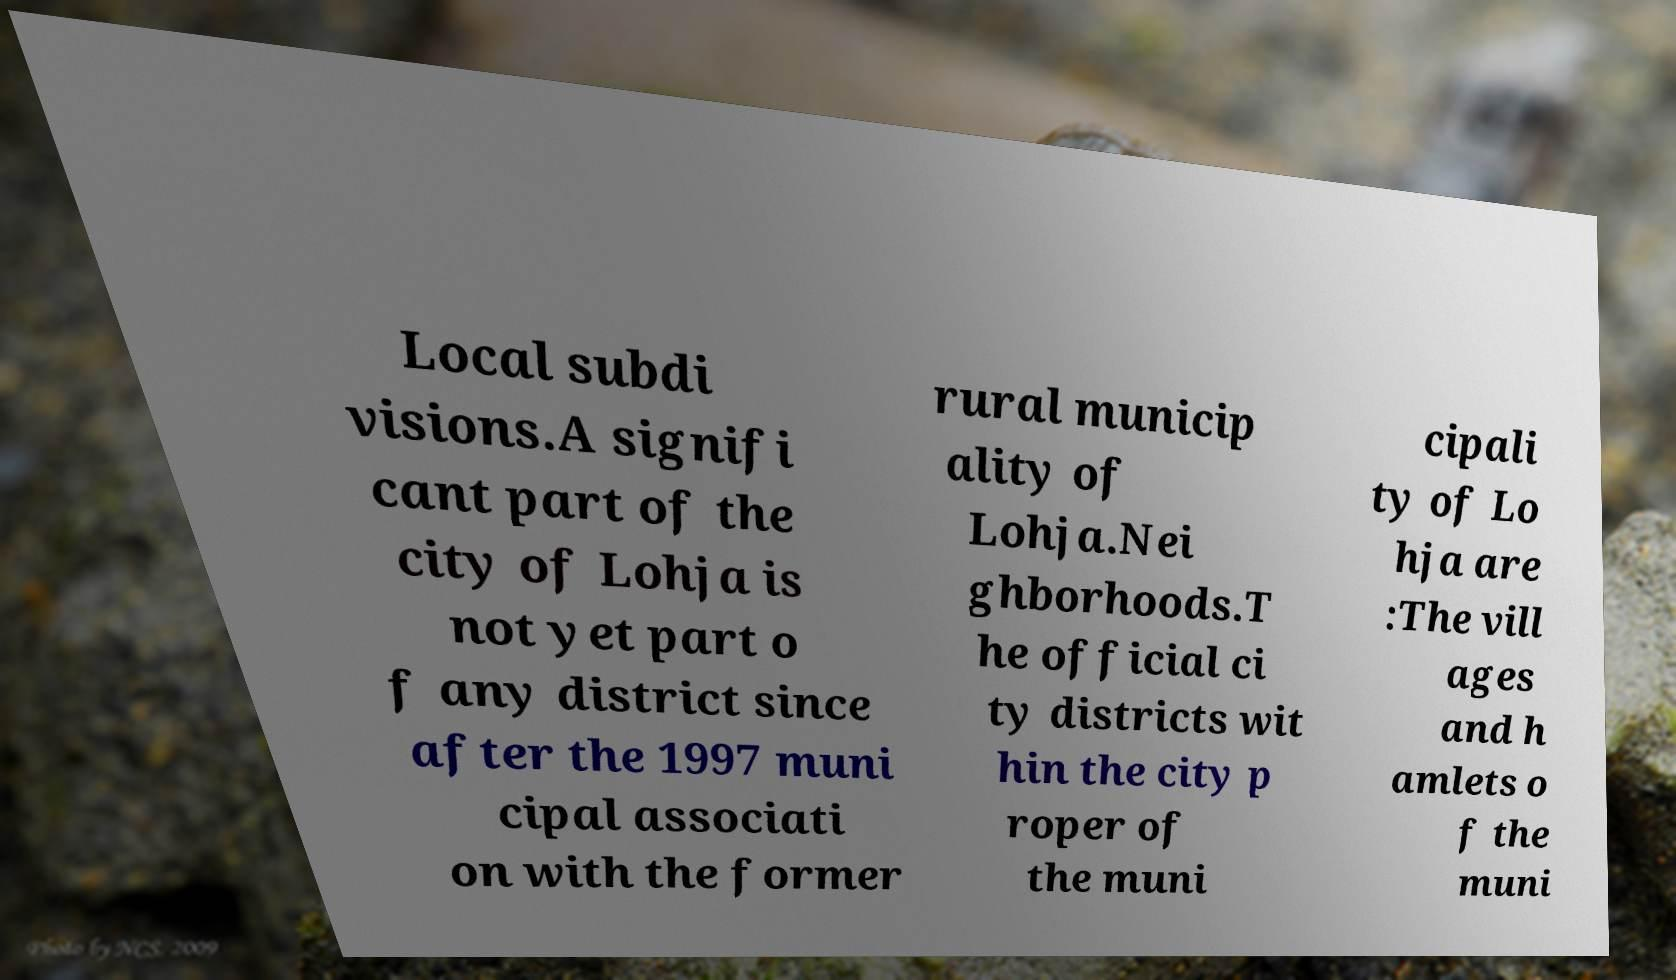Please identify and transcribe the text found in this image. Local subdi visions.A signifi cant part of the city of Lohja is not yet part o f any district since after the 1997 muni cipal associati on with the former rural municip ality of Lohja.Nei ghborhoods.T he official ci ty districts wit hin the city p roper of the muni cipali ty of Lo hja are :The vill ages and h amlets o f the muni 